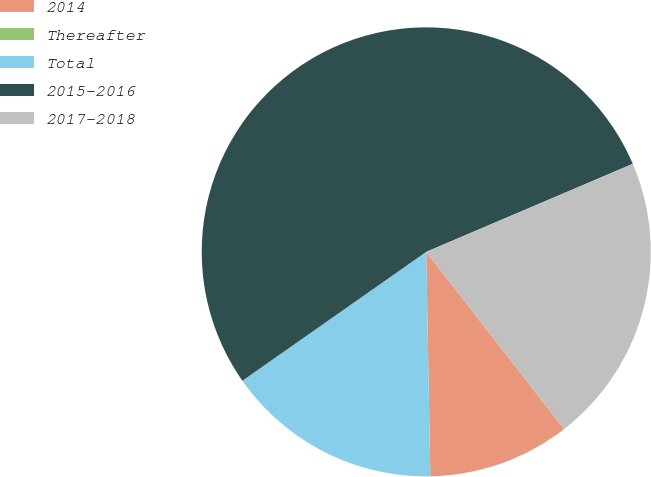<chart> <loc_0><loc_0><loc_500><loc_500><pie_chart><fcel>2014<fcel>Thereafter<fcel>Total<fcel>2015-2016<fcel>2017-2018<nl><fcel>10.23%<fcel>0.0%<fcel>15.56%<fcel>53.32%<fcel>20.89%<nl></chart> 